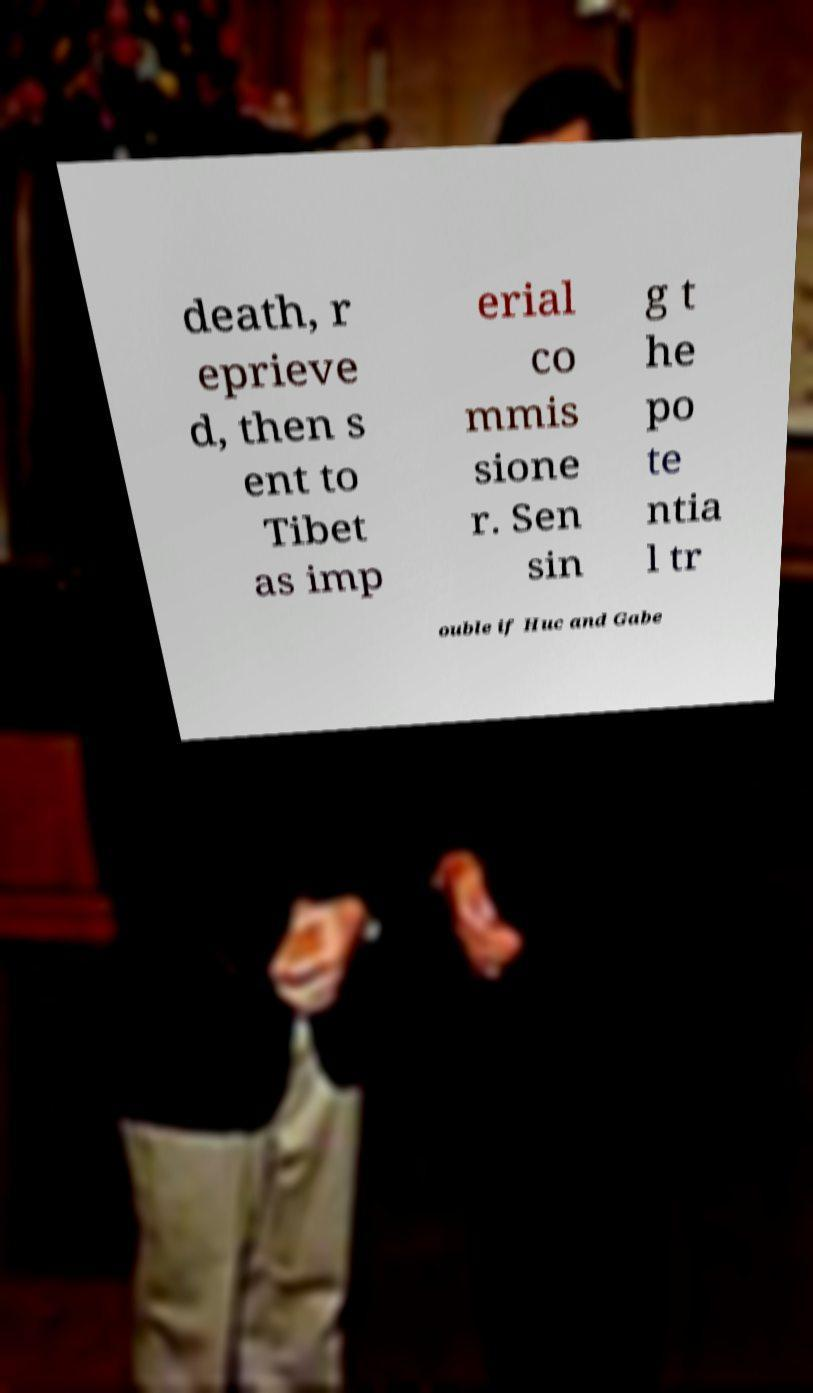I need the written content from this picture converted into text. Can you do that? death, r eprieve d, then s ent to Tibet as imp erial co mmis sione r. Sen sin g t he po te ntia l tr ouble if Huc and Gabe 